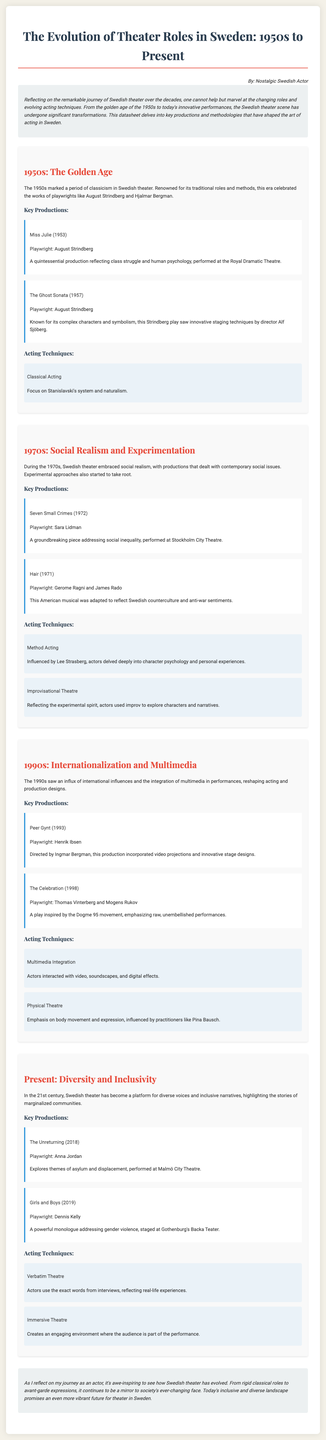What role did August Strindberg play in the 1950s? August Strindberg's works were celebrated during this era, showcasing traditional roles and methods.
Answer: Traditional roles What is a key production from the 1990s? The production "Peer Gynt" directed by Ingmar Bergman is a notable piece from the 1990s that integrated multimedia.
Answer: Peer Gynt What acting technique became prominent in the 1970s? The 1970s saw the rise of Method Acting, focusing on character psychology and personal experiences.
Answer: Method Acting What themes are explored in "The Unreturning"? "The Unreturning" examines themes related to asylum and displacement.
Answer: Asylum and displacement Which theater movement influenced "The Celebration"? "The Celebration" was inspired by the Dogme 95 movement emphasizing raw performances.
Answer: Dogme 95 How many productions were highlighted in the 1950s section? The document mentions two key productions from the 1950s, providing insight into the era's theater.
Answer: Two What is the significance of verbatim theatre in present-day Swedish theater? Actors in verbatim theatre use the actual words from interviews to reflect real-life experiences.
Answer: Real-life experiences Which renowned director worked on "Peer Gynt"? Ingmar Bergman, a notable director, worked on this production in the 1990s.
Answer: Ingmar Bergman What kind of theater became more prominent in the 21st century? The 21st century saw an increase in immersive theatre, making the audience part of the performance.
Answer: Immersive theatre 